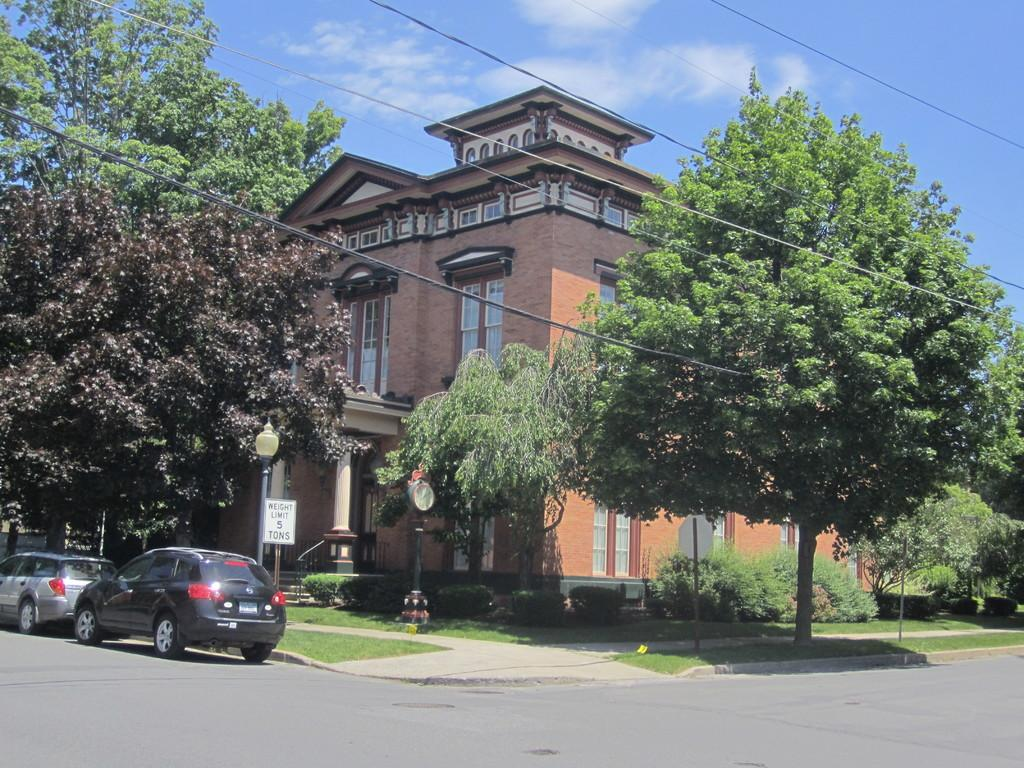What type of structure is visible in the image? There is a building in the image. What other natural elements can be seen in the image? There are trees in the image. What type of transportation is present on the road in the image? There are cars on the road in the image. What is visible at the top of the image? The sky is visible at the top of the image. What else can be seen at the top of the image? There are wires at the top of the image. Can you see the veil of a bride in the image? There is no veil or bride present in the image. How many muscles are visible on the trees in the image? Trees do not have muscles, so this question cannot be answered. 